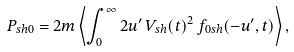Convert formula to latex. <formula><loc_0><loc_0><loc_500><loc_500>P _ { s h 0 } = 2 m \left \langle \int _ { 0 } ^ { \infty } 2 u ^ { \prime } \, V _ { s h } ( t ) ^ { 2 } \, f _ { 0 s h } ( - u ^ { \prime } , t ) \right \rangle ,</formula> 